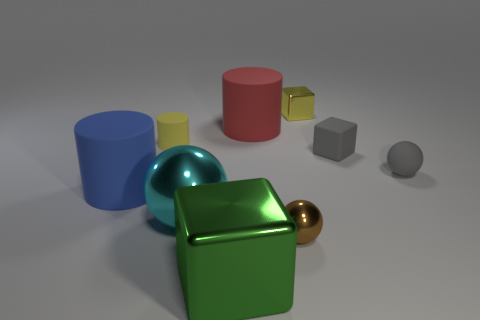Subtract all big red rubber cylinders. How many cylinders are left? 2 Subtract all gray balls. How many balls are left? 2 Subtract all blocks. How many objects are left? 6 Subtract 1 spheres. How many spheres are left? 2 Subtract all purple spheres. Subtract all blue blocks. How many spheres are left? 3 Subtract all green balls. How many gray cylinders are left? 0 Subtract all yellow rubber cylinders. Subtract all small yellow things. How many objects are left? 6 Add 2 red cylinders. How many red cylinders are left? 3 Add 9 yellow shiny blocks. How many yellow shiny blocks exist? 10 Subtract 0 cyan cylinders. How many objects are left? 9 